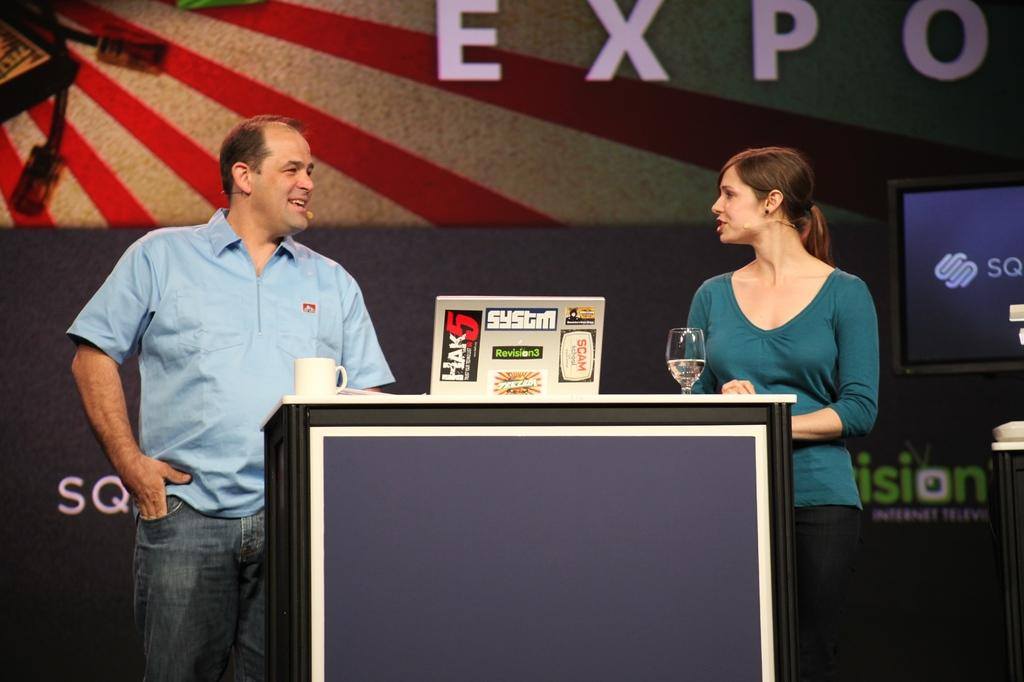How many people are in the image? There is a man and a woman in the image. What are the man and woman doing in the image? The man and woman are standing and talking. What is on the table in the image? There are cups, glasses, and boards on the table. Can you hear the woman laughing in the image? There is no sound in the image, so it is not possible to hear anyone laughing. 